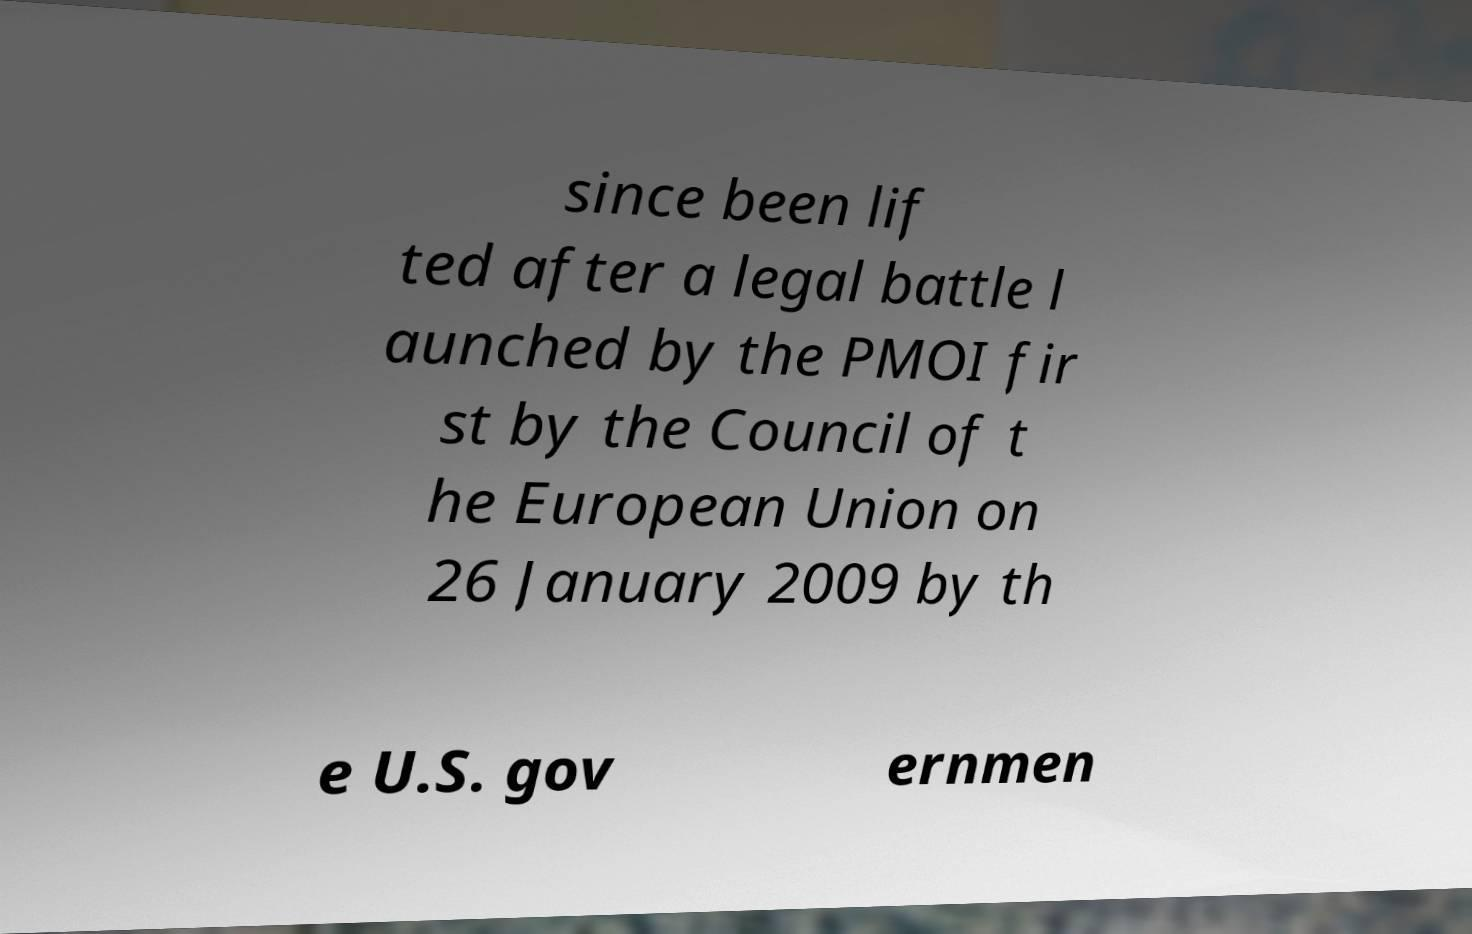There's text embedded in this image that I need extracted. Can you transcribe it verbatim? since been lif ted after a legal battle l aunched by the PMOI fir st by the Council of t he European Union on 26 January 2009 by th e U.S. gov ernmen 